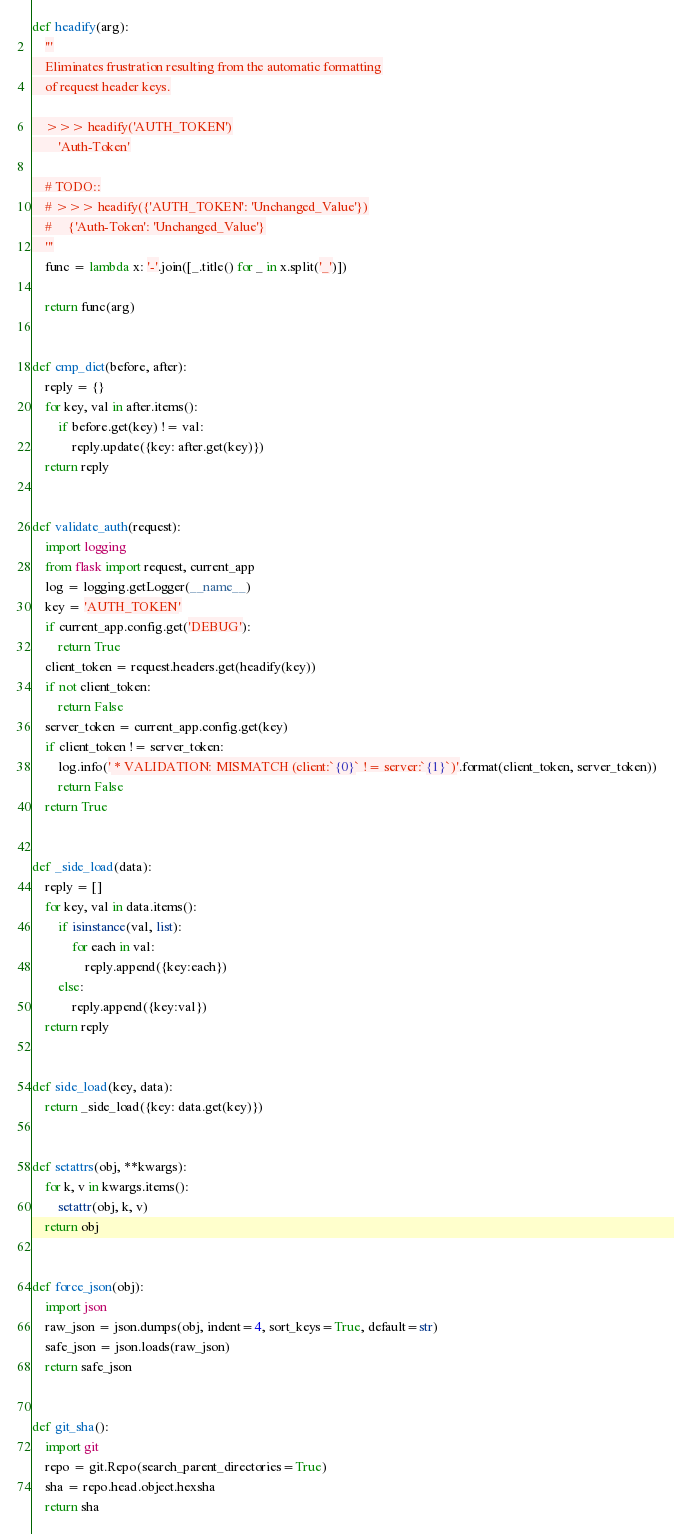Convert code to text. <code><loc_0><loc_0><loc_500><loc_500><_Python_>
def headify(arg):
    '''
    Eliminates frustration resulting from the automatic formatting
    of request header keys.

    >>> headify('AUTH_TOKEN')
        'Auth-Token'

    # TODO::
    # >>> headify({'AUTH_TOKEN': 'Unchanged_Value'})
    #     {'Auth-Token': 'Unchanged_Value'}
    '''
    func = lambda x: '-'.join([_.title() for _ in x.split('_')])

    return func(arg)


def cmp_dict(before, after):
    reply = {}
    for key, val in after.items():
        if before.get(key) != val:
            reply.update({key: after.get(key)})
    return reply


def validate_auth(request):
    import logging
    from flask import request, current_app
    log = logging.getLogger(__name__)
    key = 'AUTH_TOKEN'
    if current_app.config.get('DEBUG'):
        return True
    client_token = request.headers.get(headify(key))
    if not client_token:
        return False
    server_token = current_app.config.get(key)
    if client_token != server_token:
        log.info(' * VALIDATION: MISMATCH (client:`{0}` != server:`{1}`)'.format(client_token, server_token))
        return False
    return True


def _side_load(data):
    reply = []
    for key, val in data.items():
        if isinstance(val, list):
            for each in val:
                reply.append({key:each})
        else:
            reply.append({key:val})
    return reply


def side_load(key, data):
    return _side_load({key: data.get(key)})


def setattrs(obj, **kwargs):
    for k, v in kwargs.items():
        setattr(obj, k, v)
    return obj


def force_json(obj):
    import json
    raw_json = json.dumps(obj, indent=4, sort_keys=True, default=str)
    safe_json = json.loads(raw_json)
    return safe_json


def git_sha():
    import git
    repo = git.Repo(search_parent_directories=True)
    sha = repo.head.object.hexsha
    return sha
</code> 